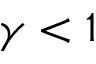<formula> <loc_0><loc_0><loc_500><loc_500>\gamma < 1</formula> 